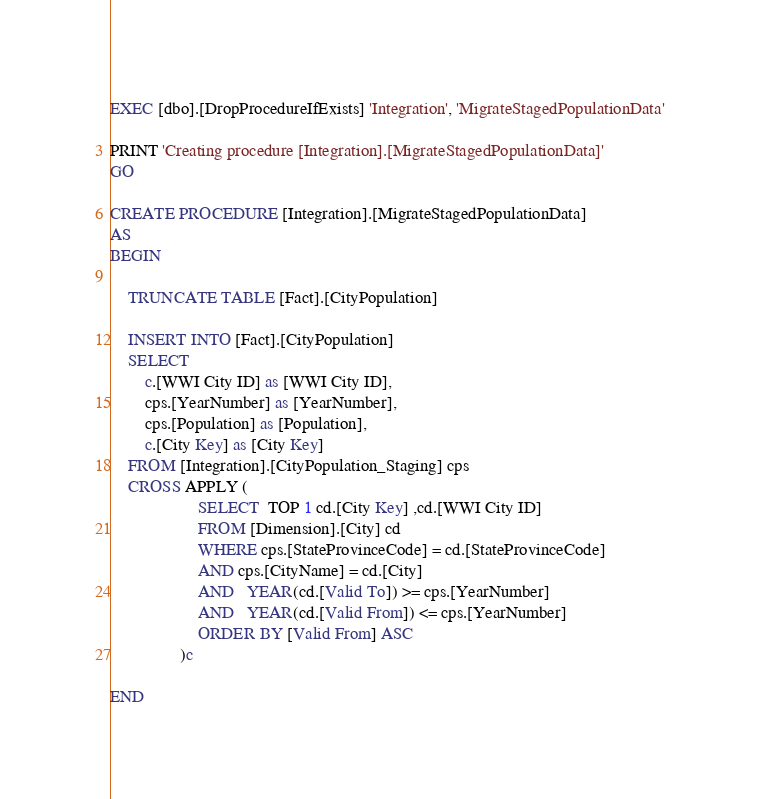Convert code to text. <code><loc_0><loc_0><loc_500><loc_500><_SQL_>EXEC [dbo].[DropProcedureIfExists] 'Integration', 'MigrateStagedPopulationData'

PRINT 'Creating procedure [Integration].[MigrateStagedPopulationData]'
GO

CREATE PROCEDURE [Integration].[MigrateStagedPopulationData]
AS
BEGIN
	
	TRUNCATE TABLE [Fact].[CityPopulation]

	INSERT INTO [Fact].[CityPopulation]
	SELECT     
		c.[WWI City ID] as [WWI City ID],
		cps.[YearNumber] as [YearNumber], 
		cps.[Population] as [Population],
		c.[City Key] as [City Key]
	FROM [Integration].[CityPopulation_Staging] cps
	CROSS APPLY (
					SELECT  TOP 1 cd.[City Key] ,cd.[WWI City ID]
					FROM [Dimension].[City] cd
					WHERE cps.[StateProvinceCode] = cd.[StateProvinceCode] 
					AND cps.[CityName] = cd.[City]
					AND   YEAR(cd.[Valid To]) >= cps.[YearNumber] 
					AND   YEAR(cd.[Valid From]) <= cps.[YearNumber]  
					ORDER BY [Valid From] ASC
				)c

END</code> 